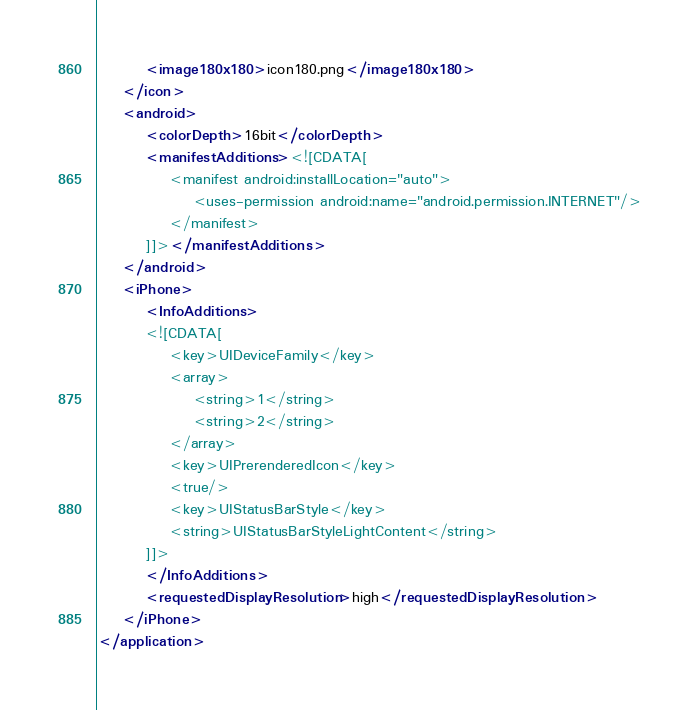<code> <loc_0><loc_0><loc_500><loc_500><_XML_>		<image180x180>icon180.png</image180x180>
	</icon>
	<android>
		<colorDepth>16bit</colorDepth>
		<manifestAdditions><![CDATA[
			<manifest android:installLocation="auto">
			    <uses-permission android:name="android.permission.INTERNET"/>
			</manifest>
		]]></manifestAdditions>
	</android>
	<iPhone>
		<InfoAdditions>
		<![CDATA[
			<key>UIDeviceFamily</key> 
			<array> 
				<string>1</string>
				<string>2</string>
			</array>
			<key>UIPrerenderedIcon</key>
			<true/>
			<key>UIStatusBarStyle</key>
			<string>UIStatusBarStyleLightContent</string>
		]]> 
		</InfoAdditions>
		<requestedDisplayResolution>high</requestedDisplayResolution>
	</iPhone>
</application></code> 